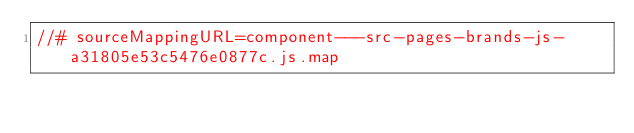<code> <loc_0><loc_0><loc_500><loc_500><_JavaScript_>//# sourceMappingURL=component---src-pages-brands-js-a31805e53c5476e0877c.js.map</code> 